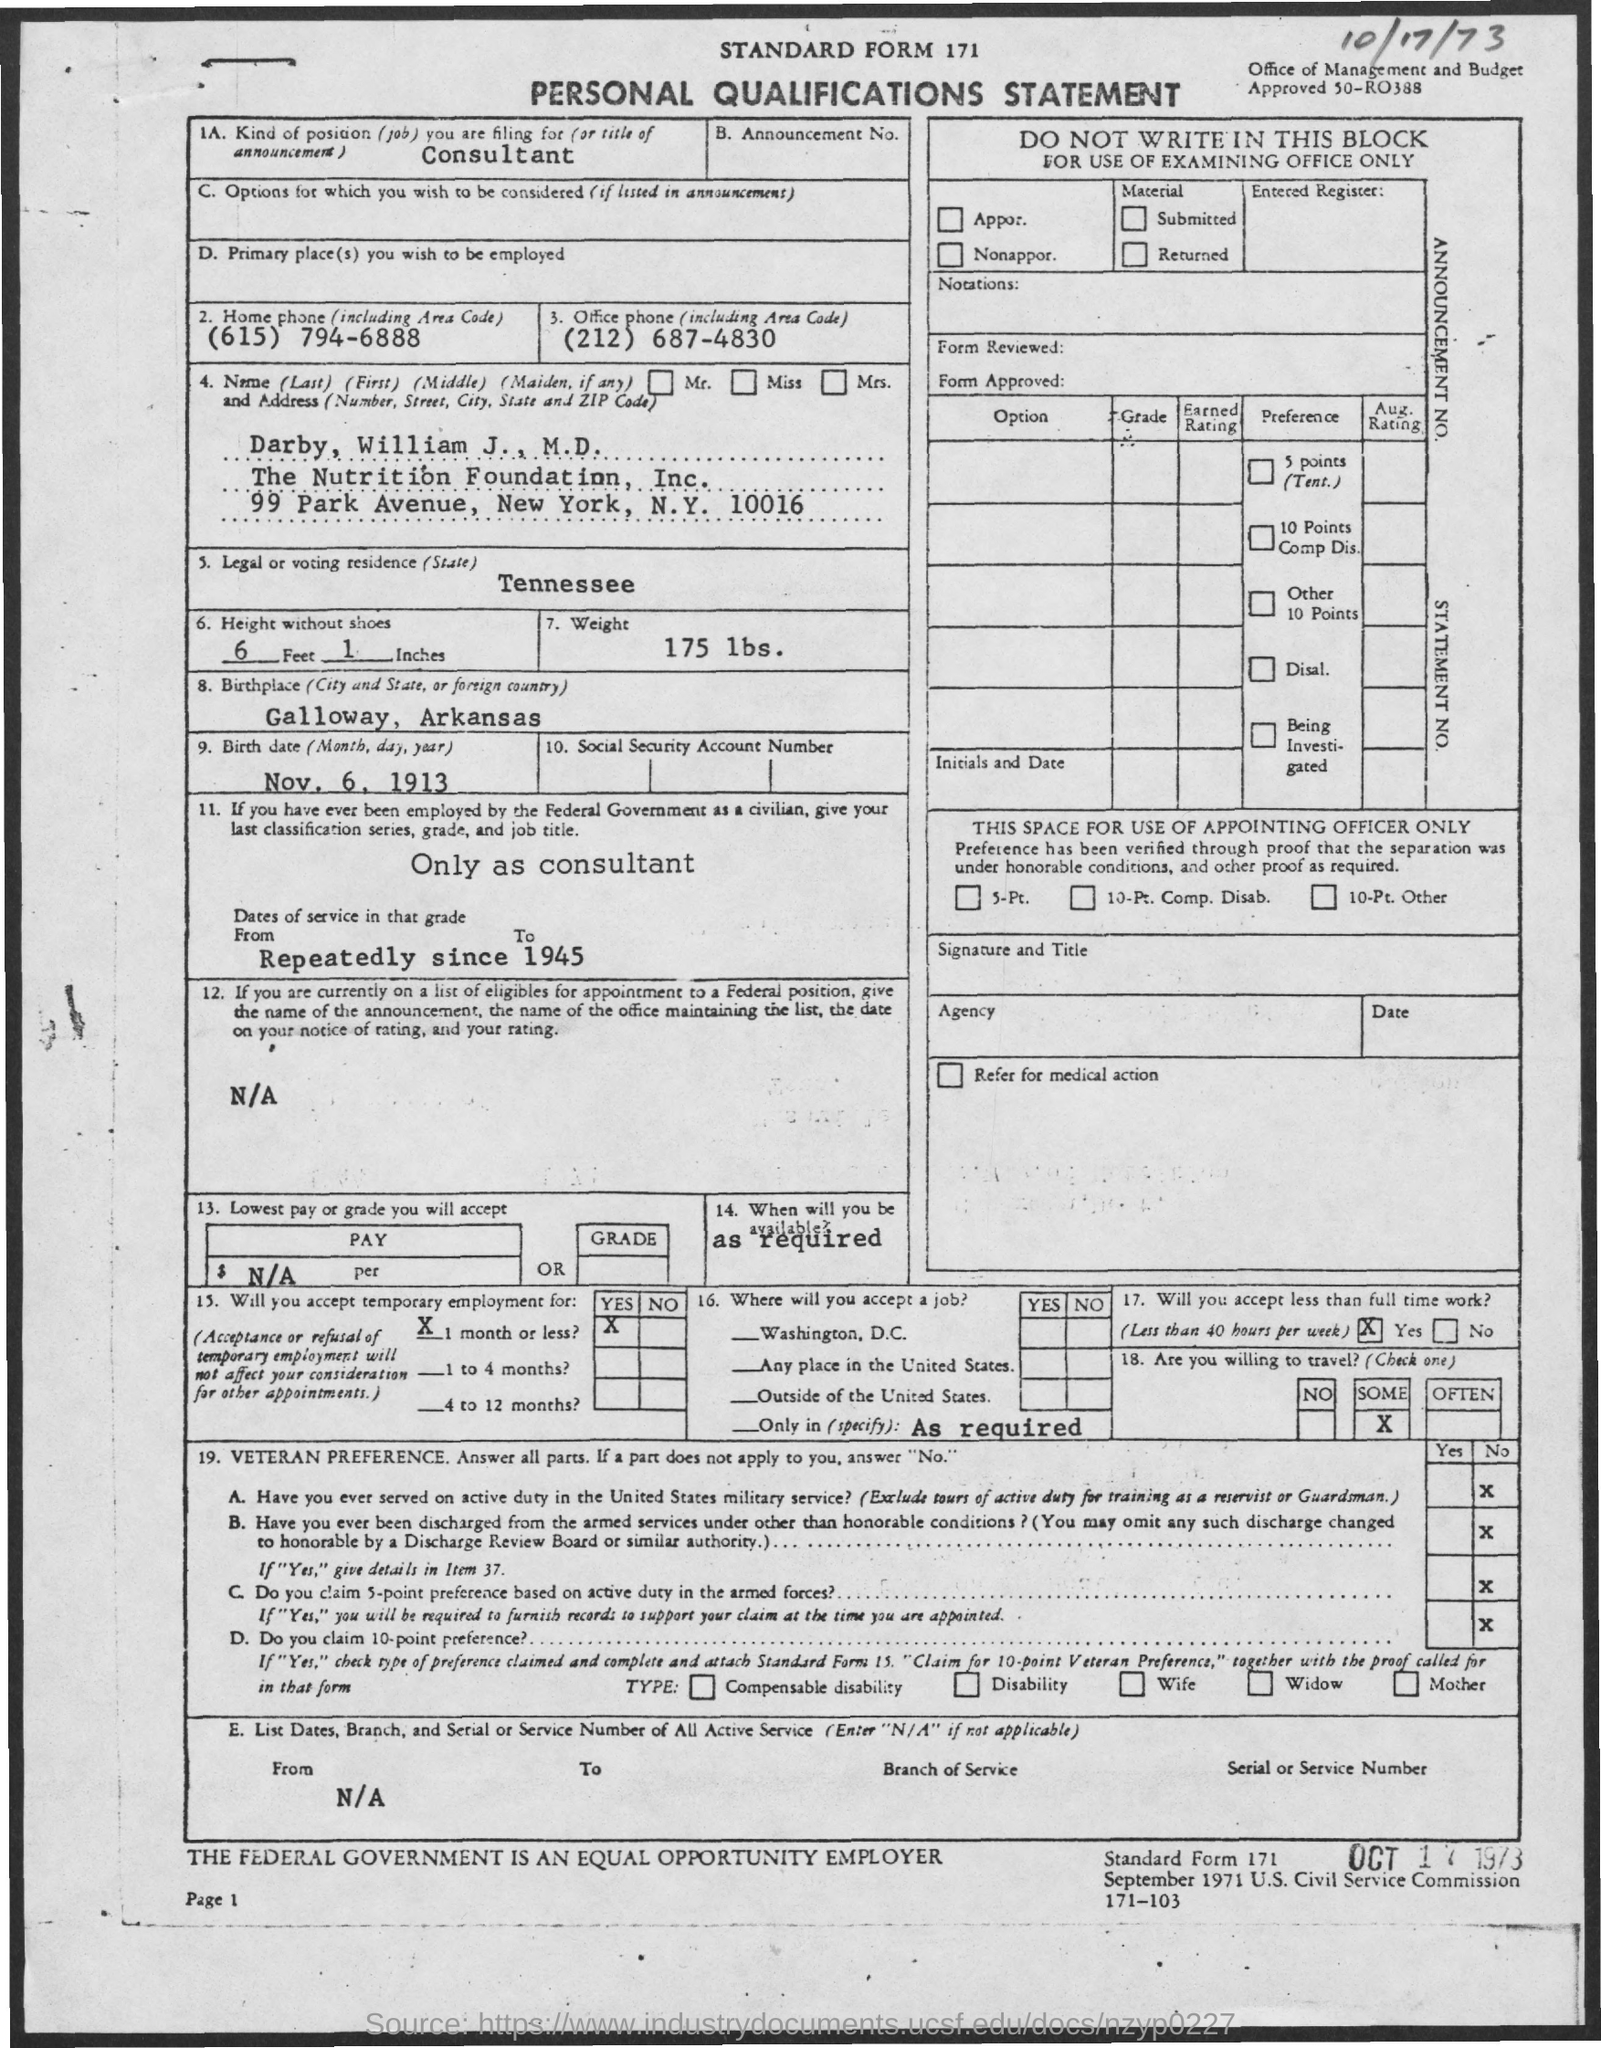Highlight a few significant elements in this photo. The office phone number is (212) 687-4830. The birthplace of the person is Galloway, Arkansas. The document in question is titled 'Personal Qualifications Statement.' The weight of 175 lbs is... I am applying for the position of consultant. 